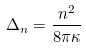Convert formula to latex. <formula><loc_0><loc_0><loc_500><loc_500>\Delta _ { n } = \frac { n ^ { 2 } } { 8 \pi \kappa }</formula> 